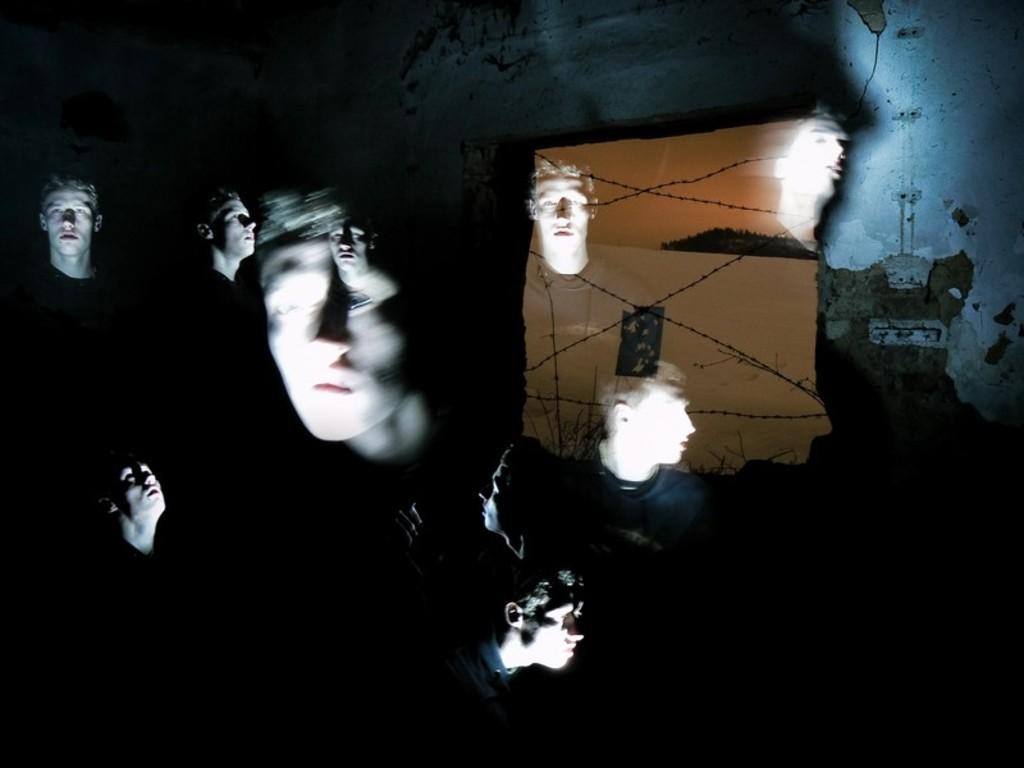What is the main subject in the foreground of the image? There is a group of people in the foreground of the image. What can be seen in the background of the image? There is a wall, a board, and a light in the background of the image. Who is the creator of the magic grip in the image? There is no mention of a magic grip or a creator in the image. 